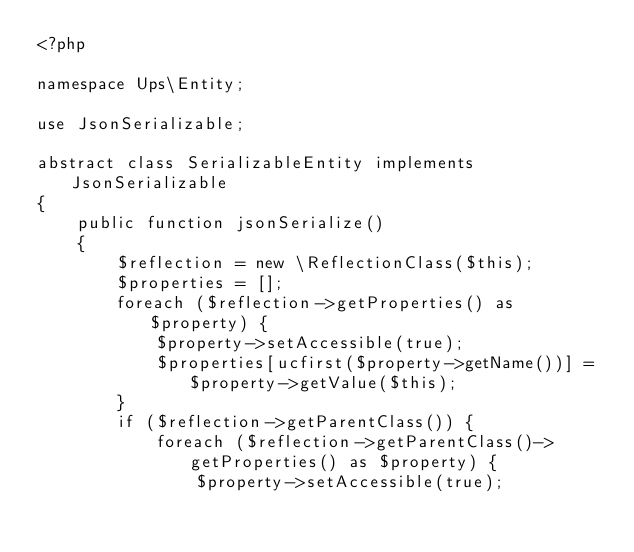<code> <loc_0><loc_0><loc_500><loc_500><_PHP_><?php

namespace Ups\Entity;

use JsonSerializable;

abstract class SerializableEntity implements JsonSerializable
{
    public function jsonSerialize()
    {
        $reflection = new \ReflectionClass($this);
        $properties = [];
        foreach ($reflection->getProperties() as $property) {
            $property->setAccessible(true);
            $properties[ucfirst($property->getName())] = $property->getValue($this);
        }
        if ($reflection->getParentClass()) {
            foreach ($reflection->getParentClass()->getProperties() as $property) {
                $property->setAccessible(true);</code> 